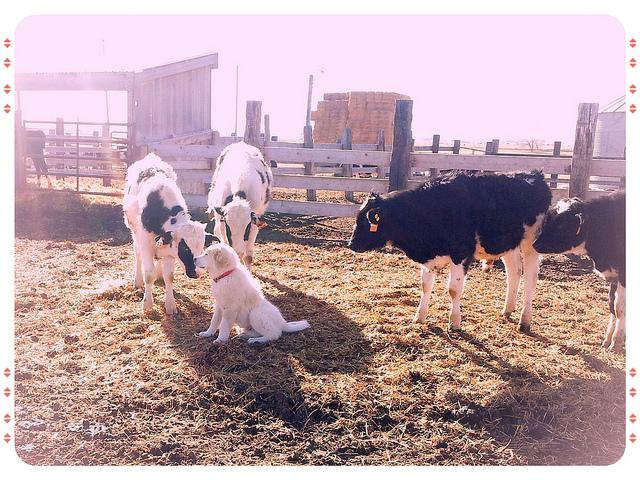What are the cows looking at? dog 